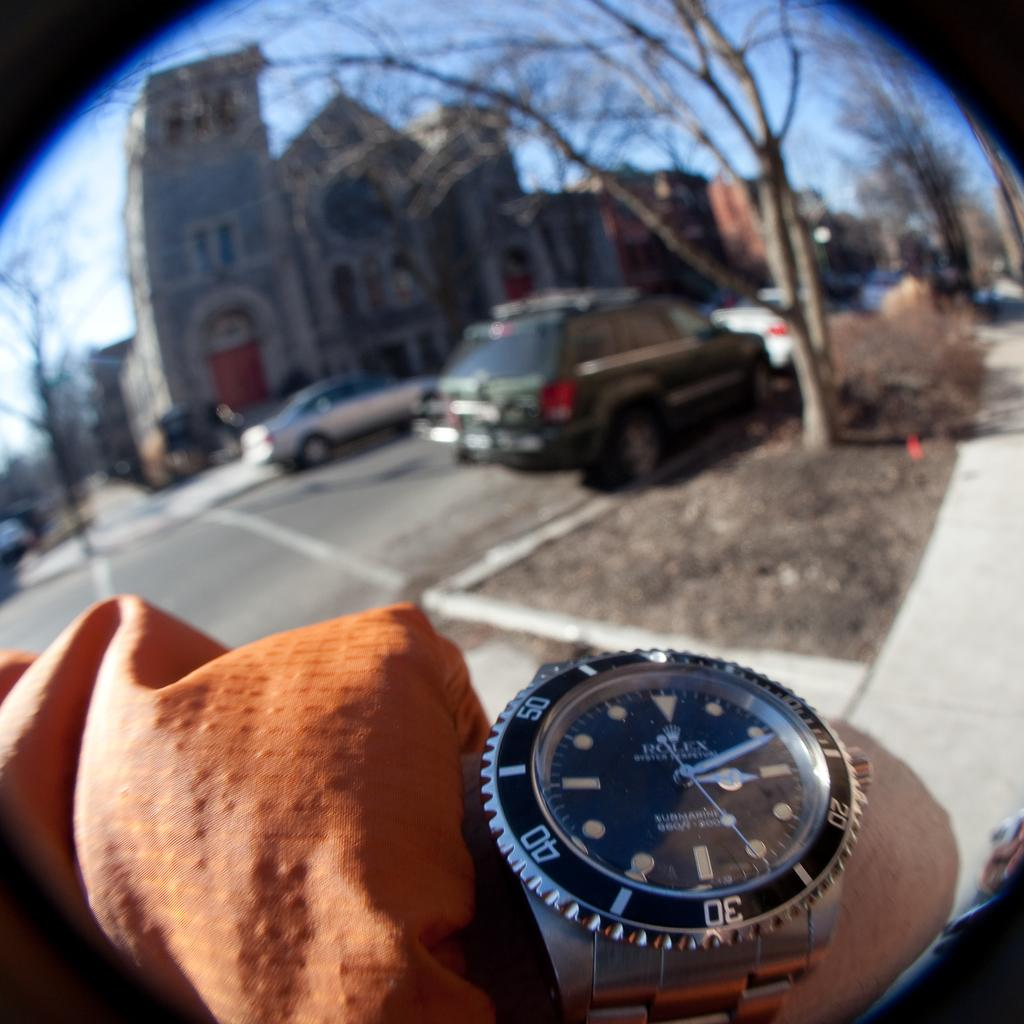<image>
Render a clear and concise summary of the photo. A Rolex watch displays the time of 3:11. 